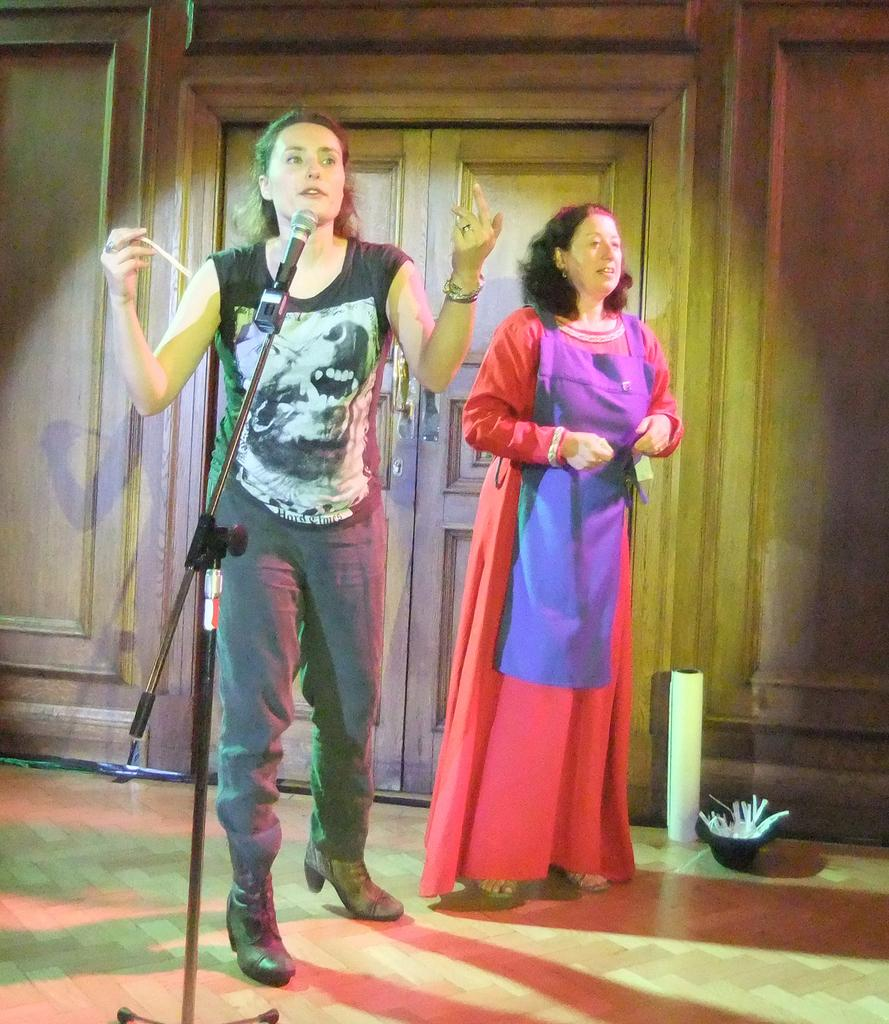How many women are in the image? There are two women in the image. What is one of the women doing in the image? One woman is talking in front of a microphone. What is the other woman doing in the image? The other woman is standing. Can you describe any architectural features in the image? There is a door visible in the image, and it is connected to a wall. What type of polish is the woman applying to her foot in the image? There is no woman applying polish to her foot in the image. In which direction is the door opening in the image? The direction in which the door is opening cannot be determined from the image. 